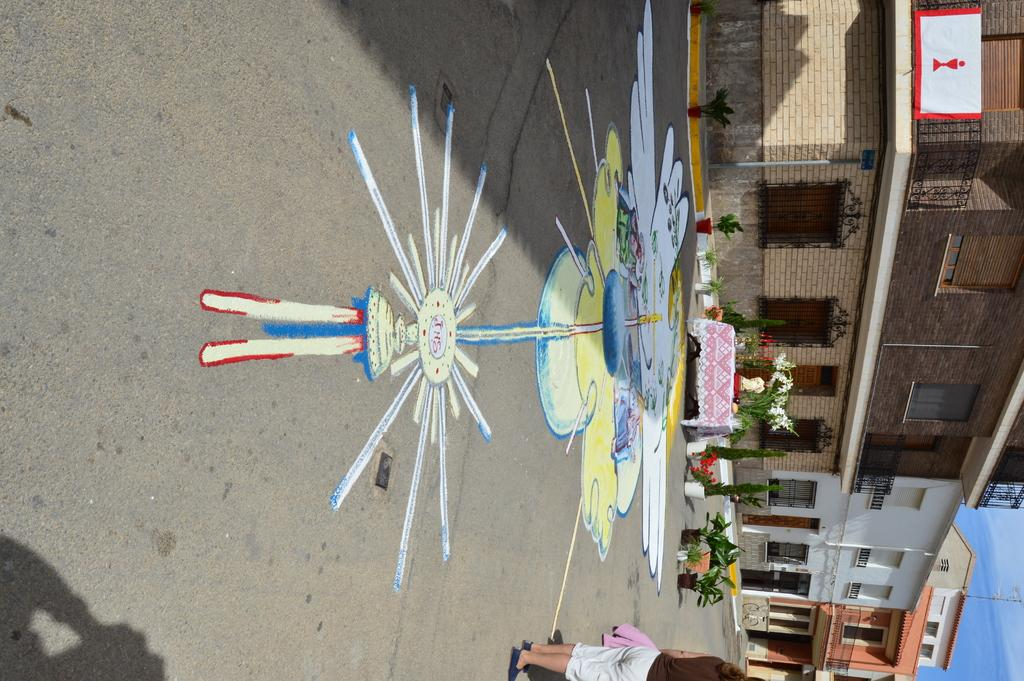What type of structures are visible in the image? There are buildings in the image. What is located in front of the buildings? There is a road in front of the buildings. What is placed on the road? There is a painting and potted plants on the road. What else can be seen on the road? There is a table with objects on the road. What reason does the kitten have for being on the table in the image? There is no kitten present in the image, so it cannot be determined if it has a reason for being on the table. 